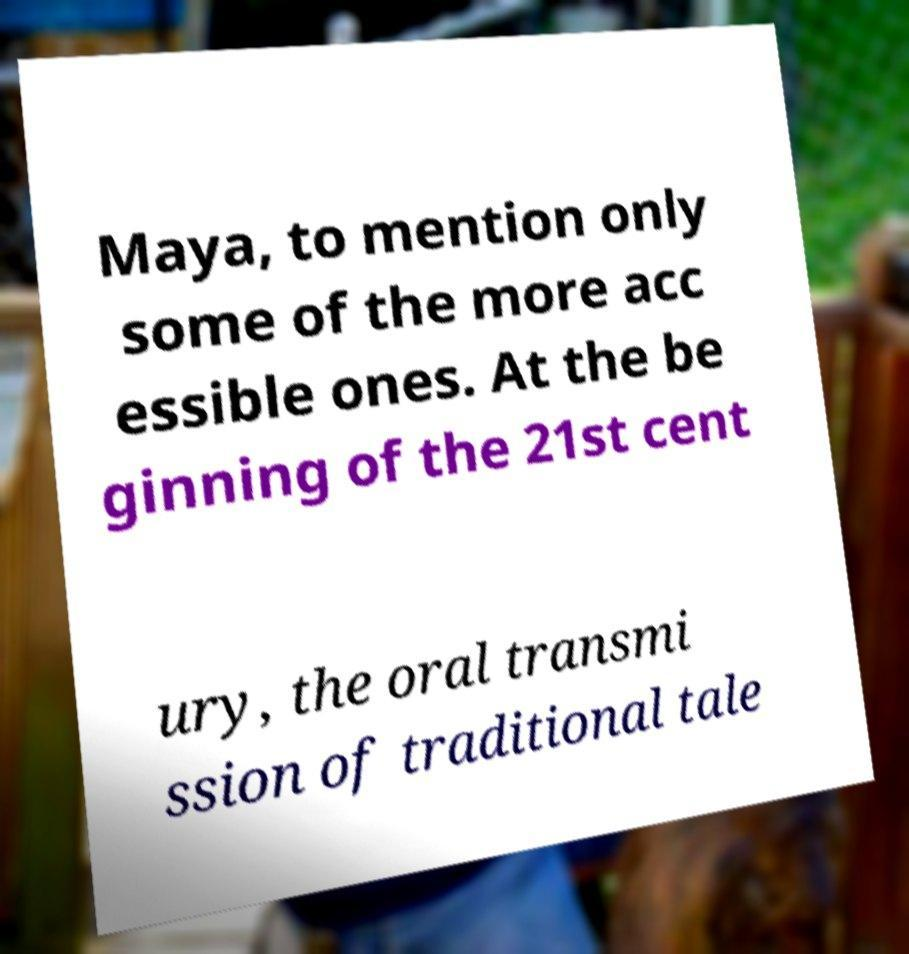There's text embedded in this image that I need extracted. Can you transcribe it verbatim? Maya, to mention only some of the more acc essible ones. At the be ginning of the 21st cent ury, the oral transmi ssion of traditional tale 